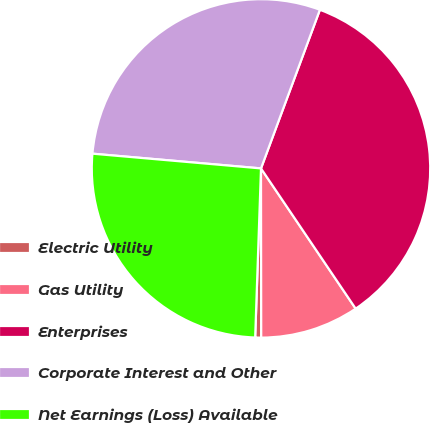Convert chart. <chart><loc_0><loc_0><loc_500><loc_500><pie_chart><fcel>Electric Utility<fcel>Gas Utility<fcel>Enterprises<fcel>Corporate Interest and Other<fcel>Net Earnings (Loss) Available<nl><fcel>0.57%<fcel>9.43%<fcel>34.89%<fcel>29.27%<fcel>25.84%<nl></chart> 